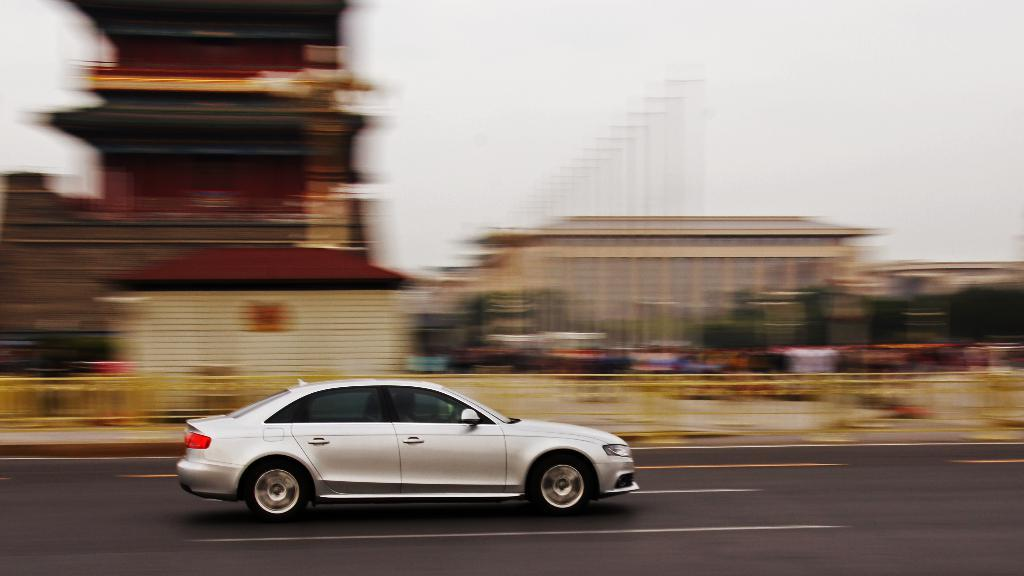What is the main subject of the image? There is a vehicle in the image. What color is the vehicle? The vehicle is white in color. Can you describe the background of the image? The background of the image is blurred. What part of the natural environment is visible in the image? The sky is visible in the image. What color is the sky in the image? The sky is white in color. Are there any visible eyes in the image? There are no visible eyes in the image, as it features a vehicle and the sky. 